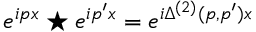<formula> <loc_0><loc_0><loc_500><loc_500>e ^ { i p x } ^ { * } e ^ { i p ^ { \prime } x } = e ^ { i \Delta ^ { ( 2 ) } ( p , p ^ { \prime } ) { x } }</formula> 